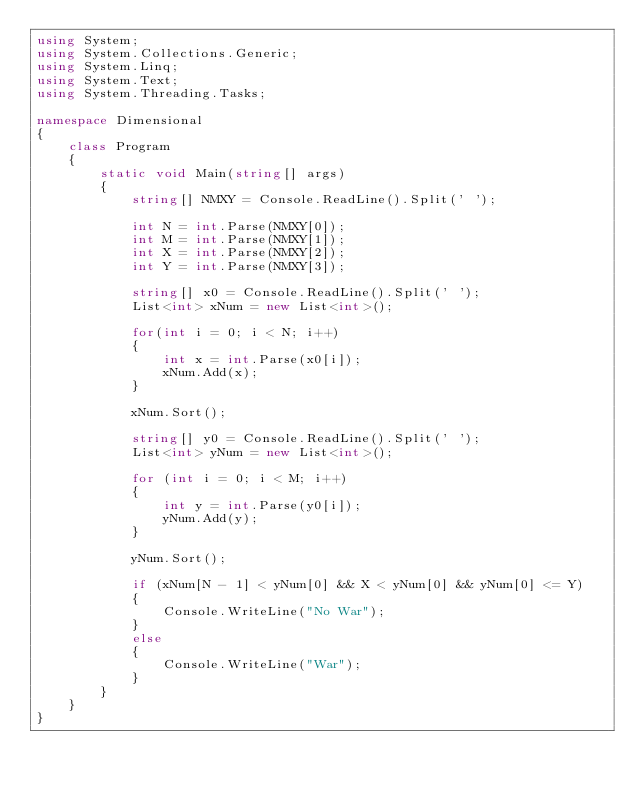<code> <loc_0><loc_0><loc_500><loc_500><_C#_>using System;
using System.Collections.Generic;
using System.Linq;
using System.Text;
using System.Threading.Tasks;

namespace Dimensional
{
    class Program
    {
        static void Main(string[] args)
        {
            string[] NMXY = Console.ReadLine().Split(' ');

            int N = int.Parse(NMXY[0]);
            int M = int.Parse(NMXY[1]);
            int X = int.Parse(NMXY[2]);
            int Y = int.Parse(NMXY[3]);

            string[] x0 = Console.ReadLine().Split(' ');
            List<int> xNum = new List<int>();

            for(int i = 0; i < N; i++)
            {
                int x = int.Parse(x0[i]);
                xNum.Add(x);
            }

            xNum.Sort();

            string[] y0 = Console.ReadLine().Split(' ');
            List<int> yNum = new List<int>();

            for (int i = 0; i < M; i++)
            {
                int y = int.Parse(y0[i]);
                yNum.Add(y);
            }

            yNum.Sort();

            if (xNum[N - 1] < yNum[0] && X < yNum[0] && yNum[0] <= Y)  
            {
                Console.WriteLine("No War");
            }
            else
            {
                Console.WriteLine("War");
            }
        }
    }
}
</code> 